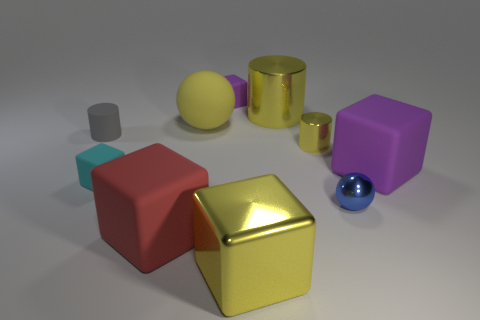Subtract all small cyan matte blocks. How many blocks are left? 4 Subtract all red spheres. How many yellow cylinders are left? 2 Subtract all gray cylinders. How many cylinders are left? 2 Add 2 small metal things. How many small metal things are left? 4 Add 2 metallic blocks. How many metallic blocks exist? 3 Subtract 0 green cylinders. How many objects are left? 10 Subtract all balls. How many objects are left? 8 Subtract all green spheres. Subtract all green cylinders. How many spheres are left? 2 Subtract all big yellow objects. Subtract all red cubes. How many objects are left? 6 